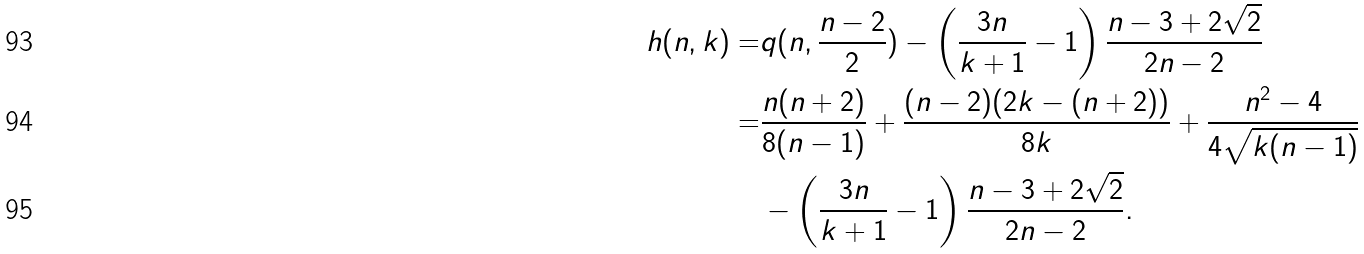<formula> <loc_0><loc_0><loc_500><loc_500>h ( n , k ) = & q ( n , \frac { n - 2 } { 2 } ) - \left ( \frac { 3 n } { k + 1 } - 1 \right ) \frac { n - 3 + 2 \sqrt { 2 } } { 2 n - 2 } \\ = & \frac { n ( n + 2 ) } { 8 ( n - 1 ) } + \frac { ( n - 2 ) ( 2 k - ( n + 2 ) ) } { 8 k } + \frac { n ^ { 2 } - 4 } { 4 \sqrt { k ( n - 1 ) } } \\ & - \left ( \frac { 3 n } { k + 1 } - 1 \right ) \frac { n - 3 + 2 \sqrt { 2 } } { 2 n - 2 } .</formula> 